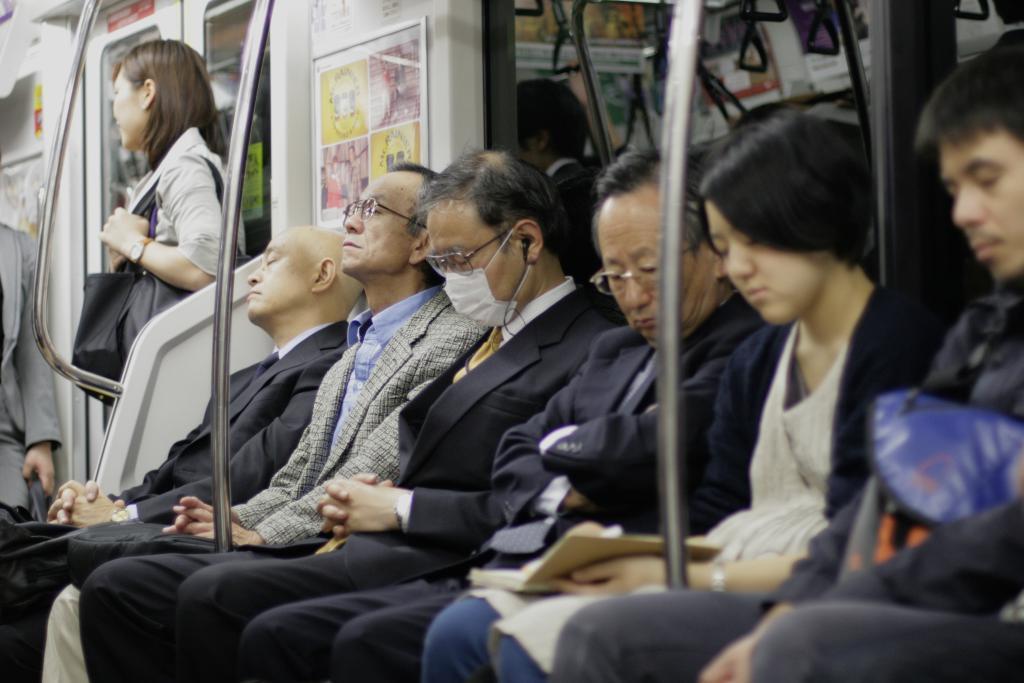Describe this image in one or two sentences. In this picture we can see a group of people inside of a vehicle, here we can see rods, posters and glass door, hangers and one woman is wearing a bag, another woman is holding a book. 